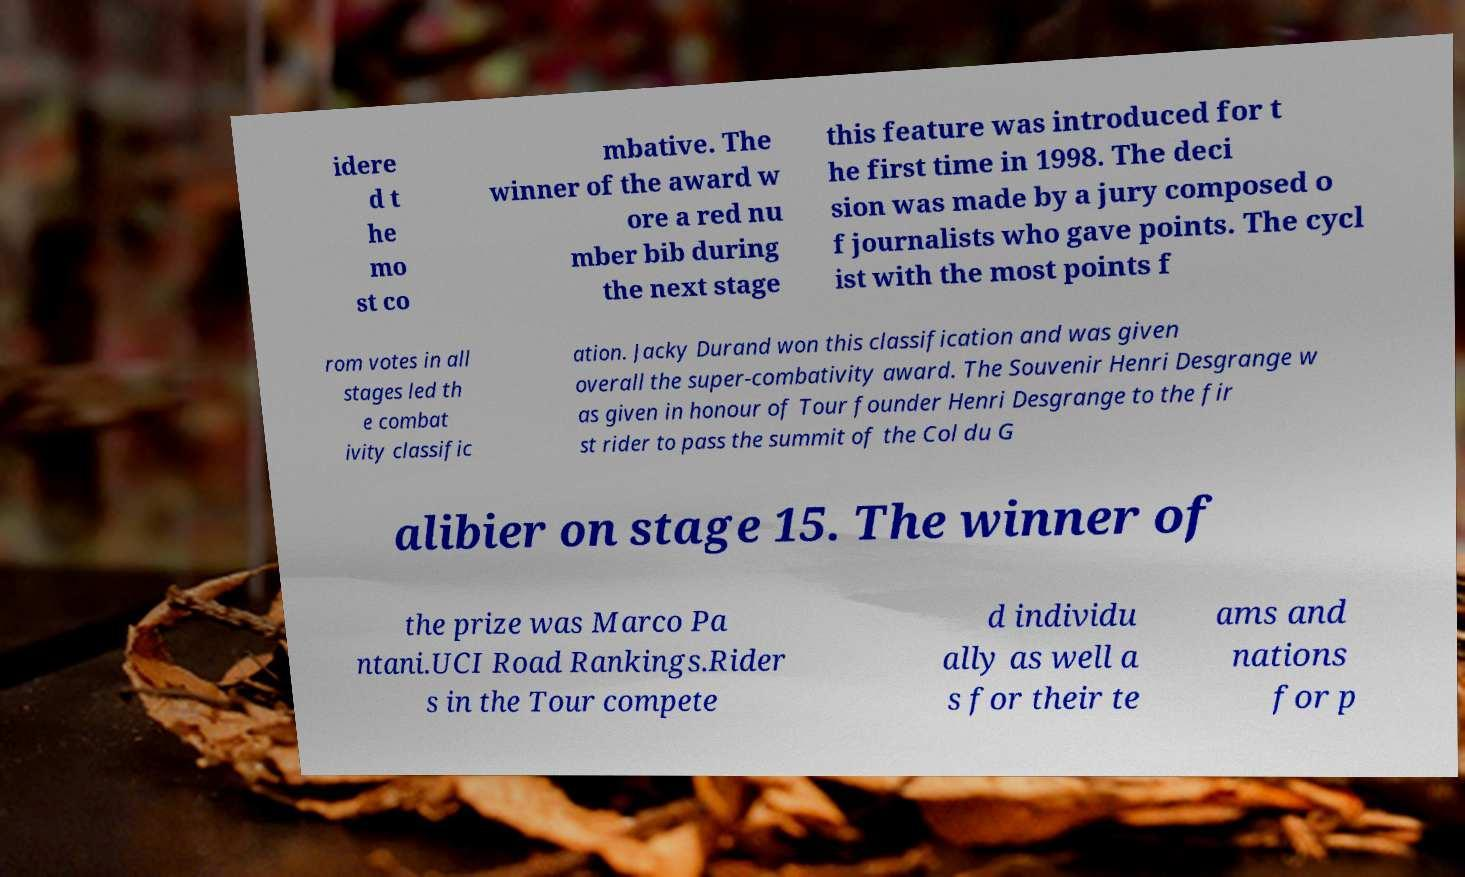There's text embedded in this image that I need extracted. Can you transcribe it verbatim? idere d t he mo st co mbative. The winner of the award w ore a red nu mber bib during the next stage this feature was introduced for t he first time in 1998. The deci sion was made by a jury composed o f journalists who gave points. The cycl ist with the most points f rom votes in all stages led th e combat ivity classific ation. Jacky Durand won this classification and was given overall the super-combativity award. The Souvenir Henri Desgrange w as given in honour of Tour founder Henri Desgrange to the fir st rider to pass the summit of the Col du G alibier on stage 15. The winner of the prize was Marco Pa ntani.UCI Road Rankings.Rider s in the Tour compete d individu ally as well a s for their te ams and nations for p 